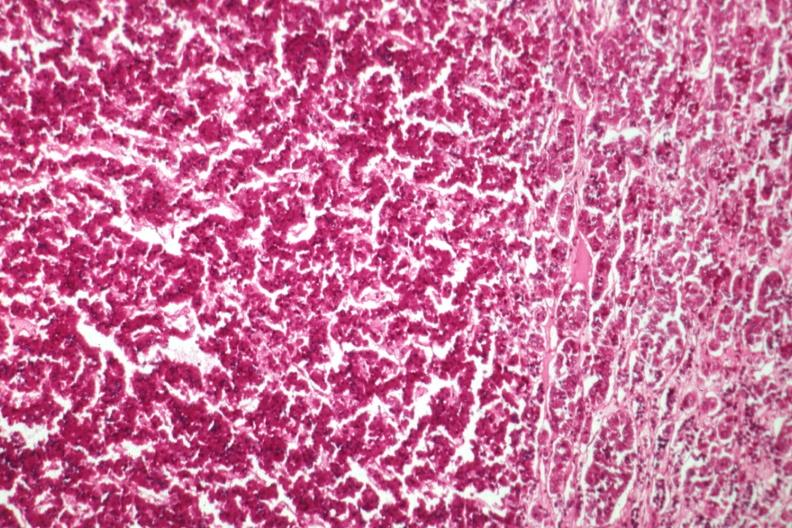s pituitary present?
Answer the question using a single word or phrase. Yes 